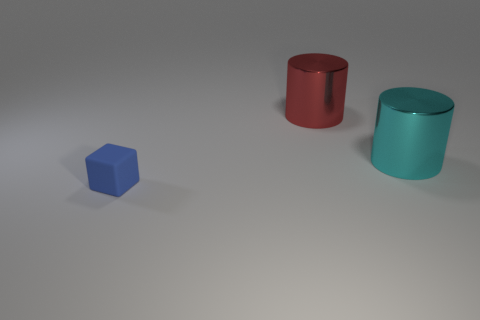Are there any other things that have the same material as the small blue block?
Give a very brief answer. No. How many objects are objects that are behind the rubber thing or objects that are on the right side of the small thing?
Make the answer very short. 2. Are there an equal number of tiny blue blocks to the left of the tiny matte thing and big things that are behind the big cyan cylinder?
Give a very brief answer. No. What shape is the shiny thing to the right of the thing that is behind the big cyan object?
Your response must be concise. Cylinder. Are there any other red objects that have the same shape as the rubber object?
Your answer should be compact. No. What number of cyan metallic things are there?
Offer a very short reply. 1. Do the big cylinder right of the red shiny cylinder and the large red thing have the same material?
Ensure brevity in your answer.  Yes. Is there another thing of the same size as the cyan shiny object?
Your answer should be compact. Yes. There is a cyan object; does it have the same shape as the thing left of the red cylinder?
Give a very brief answer. No. Is there a shiny cylinder to the left of the big thing behind the big metal object in front of the big red cylinder?
Your response must be concise. No. 